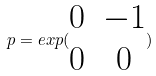<formula> <loc_0><loc_0><loc_500><loc_500>p = e x p ( \begin{matrix} 0 & - 1 \\ 0 & 0 \end{matrix} )</formula> 